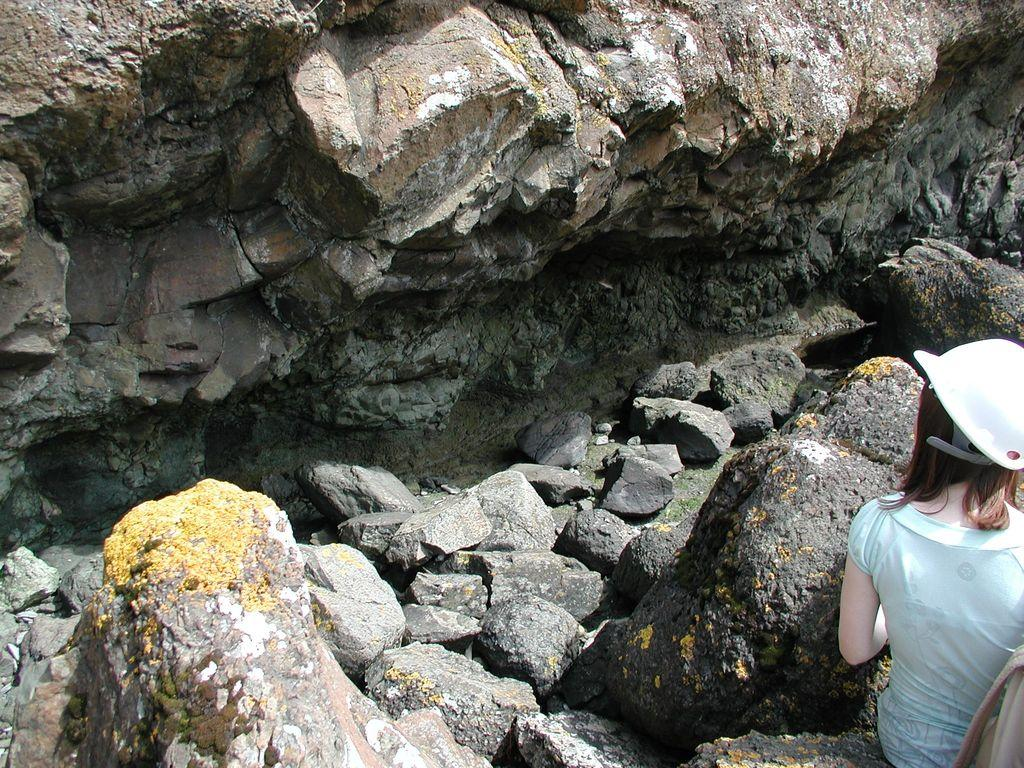Who or what is located in the bottom right corner of the image? There is a person standing in the bottom right corner of the image. What is in front of the person? There are stones in front of the person. What type of landscape feature can be seen in the image? There is a hill visible in the image. What type of coat is the person wearing in the image? The provided facts do not mention any coat or clothing worn by the person, so we cannot determine the type of coat in the image. 